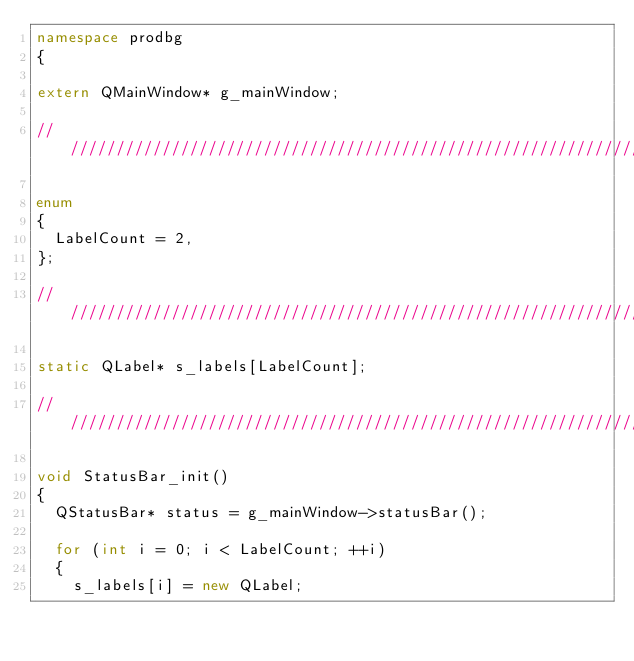Convert code to text. <code><loc_0><loc_0><loc_500><loc_500><_C++_>namespace prodbg
{

extern QMainWindow* g_mainWindow;

///////////////////////////////////////////////////////////////////////////////////////////////////////////////////////

enum
{
	LabelCount = 2,
};

///////////////////////////////////////////////////////////////////////////////////////////////////////////////////////

static QLabel* s_labels[LabelCount];

///////////////////////////////////////////////////////////////////////////////////////////////////////////////////////

void StatusBar_init()
{
	QStatusBar* status = g_mainWindow->statusBar();

	for (int i = 0; i < LabelCount; ++i)
	{
		s_labels[i] = new QLabel;</code> 